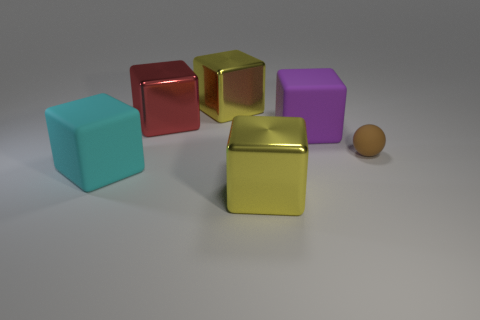What might be the significance of the single sphere compared to the multiple cubes? The solitary sphere among the cubes may be interpreted as a visual metaphor for uniqueness or individuality in contrast to uniformity. This compositional choice offers a focal point that breaks the repetition of cube shapes and can draw the viewer's attention to ponder its significance -- possibly as a commentary on standing out or being different within a structured environment.  Could the lighting in this scene suggest a specific mood or atmosphere? Indeed, the lighting used in the scene creates soft shadows and a gentle gradation of light to dark that can evoke a calm and serene mood. The absence of harsh shadows or bright highlights contributes to a feeling of stillness and contemplation, as if the objects are suspended in a tranquil moment in time. 